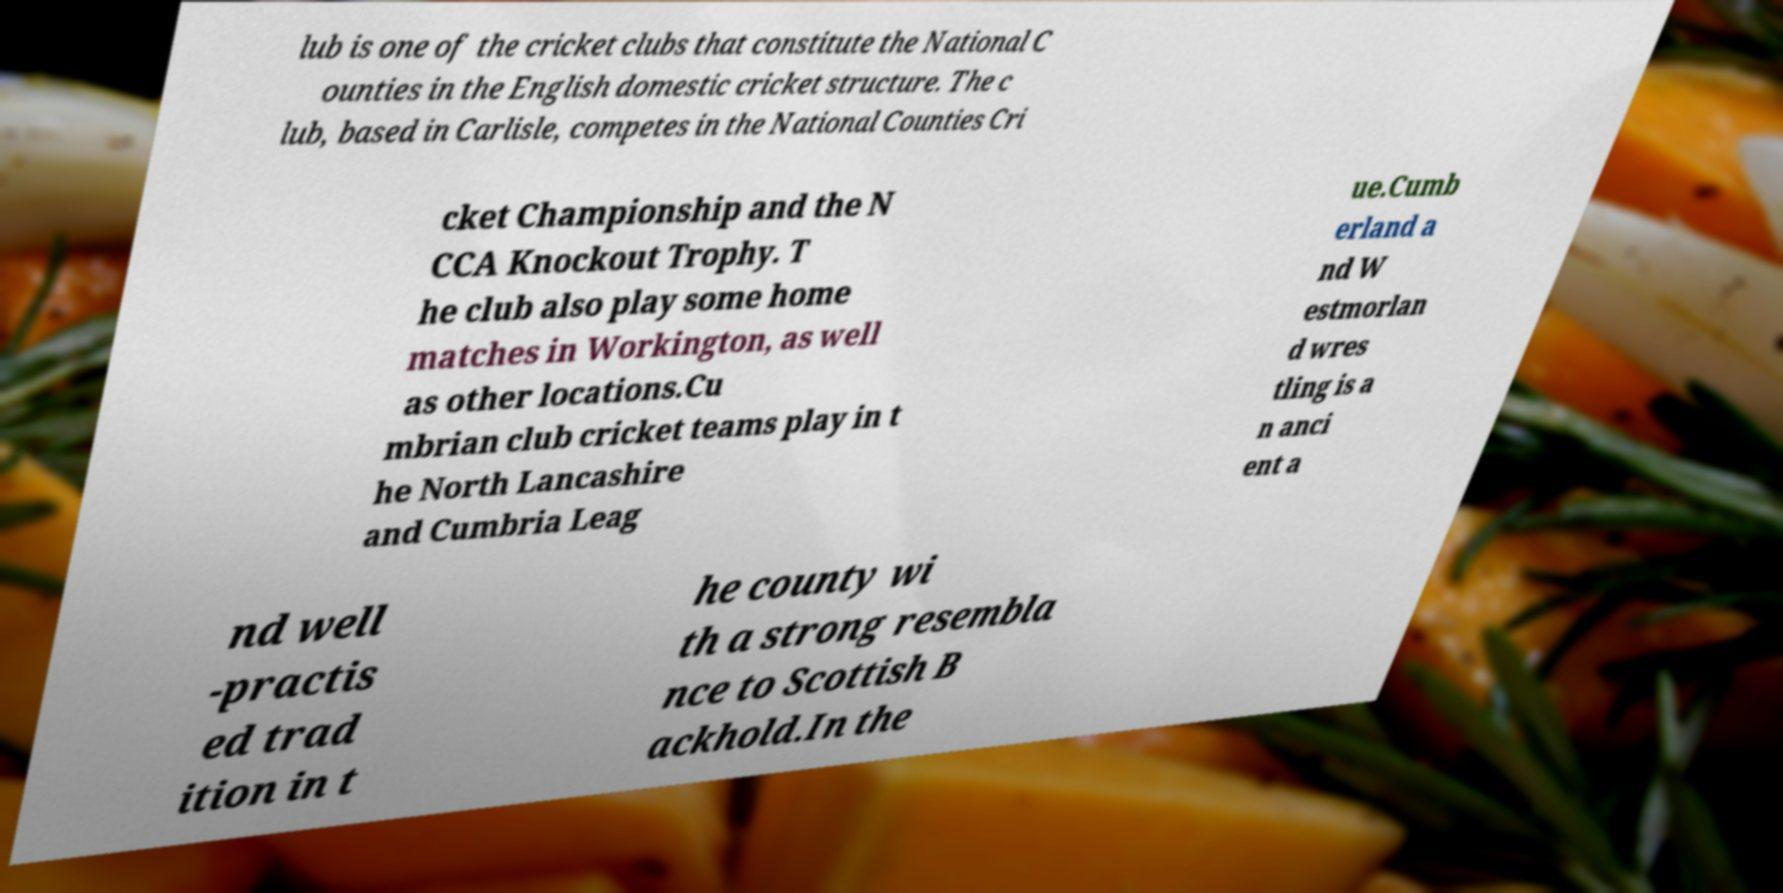I need the written content from this picture converted into text. Can you do that? lub is one of the cricket clubs that constitute the National C ounties in the English domestic cricket structure. The c lub, based in Carlisle, competes in the National Counties Cri cket Championship and the N CCA Knockout Trophy. T he club also play some home matches in Workington, as well as other locations.Cu mbrian club cricket teams play in t he North Lancashire and Cumbria Leag ue.Cumb erland a nd W estmorlan d wres tling is a n anci ent a nd well -practis ed trad ition in t he county wi th a strong resembla nce to Scottish B ackhold.In the 